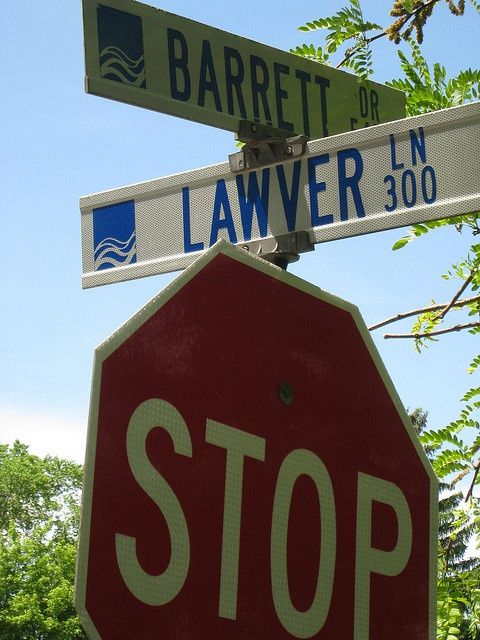Describe the objects in this image and their specific colors. I can see a stop sign in lightblue, maroon, and darkgreen tones in this image. 